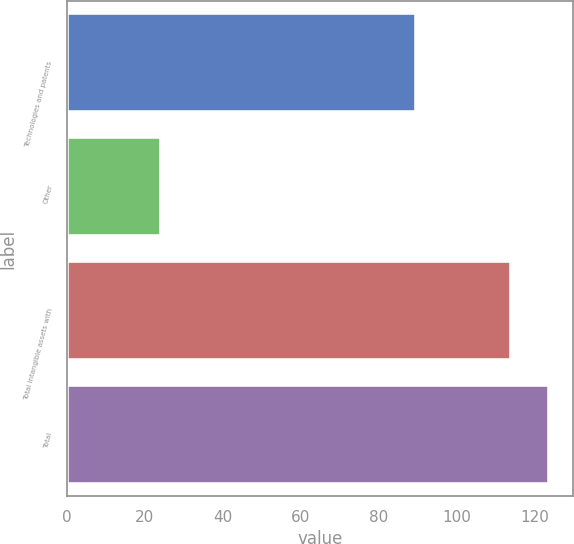Convert chart to OTSL. <chart><loc_0><loc_0><loc_500><loc_500><bar_chart><fcel>Technologies and patents<fcel>Other<fcel>Total intangible assets with<fcel>Total<nl><fcel>89.7<fcel>24.2<fcel>113.9<fcel>123.66<nl></chart> 